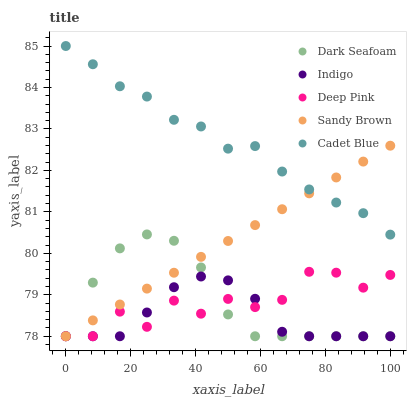Does Indigo have the minimum area under the curve?
Answer yes or no. Yes. Does Cadet Blue have the maximum area under the curve?
Answer yes or no. Yes. Does Sandy Brown have the minimum area under the curve?
Answer yes or no. No. Does Sandy Brown have the maximum area under the curve?
Answer yes or no. No. Is Sandy Brown the smoothest?
Answer yes or no. Yes. Is Deep Pink the roughest?
Answer yes or no. Yes. Is Dark Seafoam the smoothest?
Answer yes or no. No. Is Dark Seafoam the roughest?
Answer yes or no. No. Does Sandy Brown have the lowest value?
Answer yes or no. Yes. Does Cadet Blue have the highest value?
Answer yes or no. Yes. Does Sandy Brown have the highest value?
Answer yes or no. No. Is Dark Seafoam less than Cadet Blue?
Answer yes or no. Yes. Is Cadet Blue greater than Indigo?
Answer yes or no. Yes. Does Sandy Brown intersect Deep Pink?
Answer yes or no. Yes. Is Sandy Brown less than Deep Pink?
Answer yes or no. No. Is Sandy Brown greater than Deep Pink?
Answer yes or no. No. Does Dark Seafoam intersect Cadet Blue?
Answer yes or no. No. 